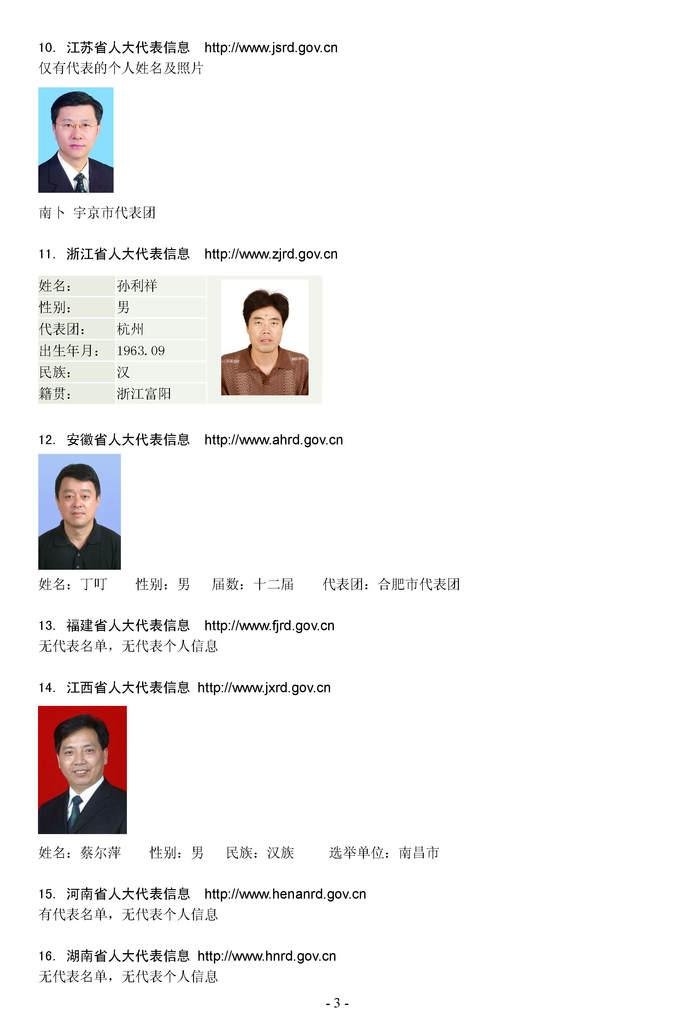What color is the text in the image? The text in the image is written in black color. What else can be seen in the image besides the text? There are pictures of persons in the image. What is the color of the background in the image? The background of the image is white. What is the income of the person in the image? There is no information about the income of any person in the image. Can you describe the event that is taking place in the image? There is no event depicted in the image; it only contains text and pictures of persons. 